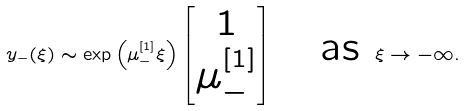Convert formula to latex. <formula><loc_0><loc_0><loc_500><loc_500>y _ { - } ( \xi ) \sim \exp \left ( \mu _ { - } ^ { [ 1 ] } \xi \right ) \begin{bmatrix} 1 \\ \mu _ { - } ^ { [ 1 ] } \end{bmatrix} \quad \text {as } \xi \to - \infty .</formula> 